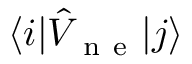Convert formula to latex. <formula><loc_0><loc_0><loc_500><loc_500>\langle i | \hat { V } _ { n e } | j \rangle</formula> 